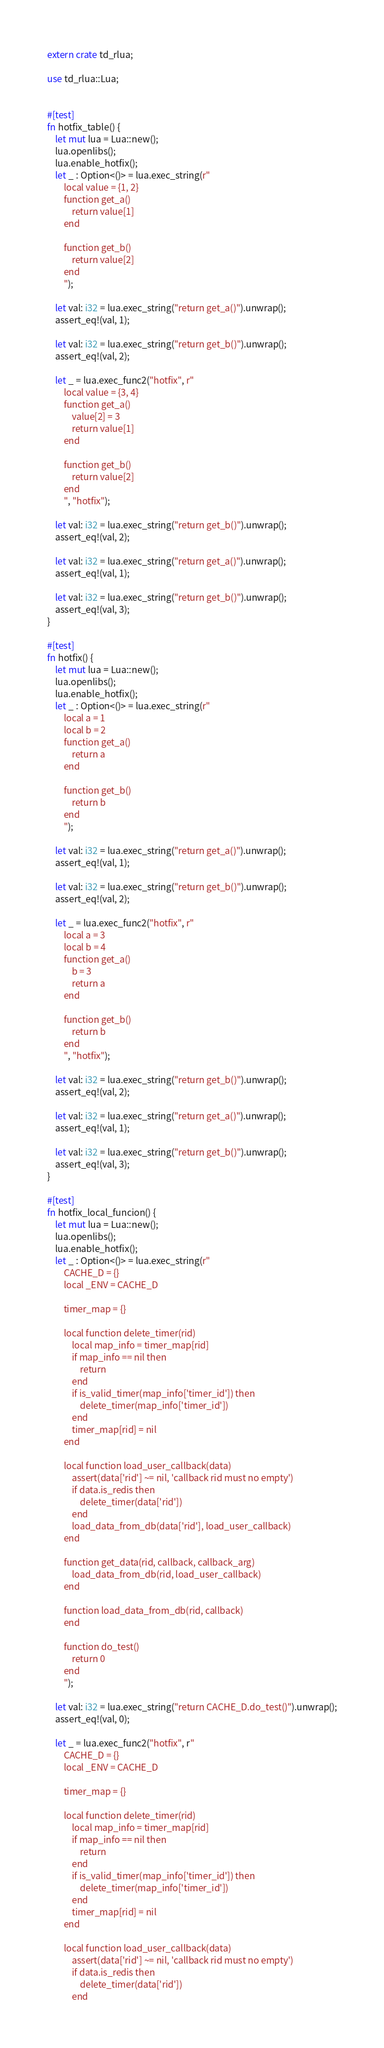<code> <loc_0><loc_0><loc_500><loc_500><_Rust_>extern crate td_rlua;

use td_rlua::Lua;


#[test]
fn hotfix_table() {
    let mut lua = Lua::new();
    lua.openlibs();
    lua.enable_hotfix();
    let _ : Option<()> = lua.exec_string(r"
        local value = {1, 2}
        function get_a()
            return value[1]
        end

        function get_b()
            return value[2]
        end
        ");

    let val: i32 = lua.exec_string("return get_a()").unwrap();
    assert_eq!(val, 1);

    let val: i32 = lua.exec_string("return get_b()").unwrap();
    assert_eq!(val, 2);

    let _ = lua.exec_func2("hotfix", r"
        local value = {3, 4}
        function get_a()
            value[2] = 3
            return value[1]
        end

        function get_b()
            return value[2]
        end
        ", "hotfix");

    let val: i32 = lua.exec_string("return get_b()").unwrap();
    assert_eq!(val, 2);

    let val: i32 = lua.exec_string("return get_a()").unwrap();
    assert_eq!(val, 1);

    let val: i32 = lua.exec_string("return get_b()").unwrap();
    assert_eq!(val, 3);
}

#[test]
fn hotfix() {
    let mut lua = Lua::new();
    lua.openlibs();
    lua.enable_hotfix();
    let _ : Option<()> = lua.exec_string(r"
        local a = 1
        local b = 2
        function get_a()
            return a
        end

        function get_b()
            return b
        end
        ");

    let val: i32 = lua.exec_string("return get_a()").unwrap();
    assert_eq!(val, 1);

    let val: i32 = lua.exec_string("return get_b()").unwrap();
    assert_eq!(val, 2);

    let _ = lua.exec_func2("hotfix", r"
        local a = 3
        local b = 4
        function get_a()
            b = 3
            return a
        end

        function get_b()
            return b
        end
        ", "hotfix");

    let val: i32 = lua.exec_string("return get_b()").unwrap();
    assert_eq!(val, 2);

    let val: i32 = lua.exec_string("return get_a()").unwrap();
    assert_eq!(val, 1);

    let val: i32 = lua.exec_string("return get_b()").unwrap();
    assert_eq!(val, 3);
}

#[test]
fn hotfix_local_funcion() {
    let mut lua = Lua::new();
    lua.openlibs();
    lua.enable_hotfix();
    let _ : Option<()> = lua.exec_string(r"
        CACHE_D = {}
        local _ENV = CACHE_D

        timer_map = {}

        local function delete_timer(rid)
            local map_info = timer_map[rid]
            if map_info == nil then
                return
            end
            if is_valid_timer(map_info['timer_id']) then
                delete_timer(map_info['timer_id'])
            end
            timer_map[rid] = nil
        end

        local function load_user_callback(data)
            assert(data['rid'] ~= nil, 'callback rid must no empty')
            if data.is_redis then
                delete_timer(data['rid'])
            end
            load_data_from_db(data['rid'], load_user_callback)
        end

        function get_data(rid, callback, callback_arg) 
            load_data_from_db(rid, load_user_callback)
        end

        function load_data_from_db(rid, callback)
        end

        function do_test()
            return 0
        end
        ");

    let val: i32 = lua.exec_string("return CACHE_D.do_test()").unwrap();
    assert_eq!(val, 0);

    let _ = lua.exec_func2("hotfix", r"
        CACHE_D = {}
        local _ENV = CACHE_D

        timer_map = {}

        local function delete_timer(rid)
            local map_info = timer_map[rid]
            if map_info == nil then
                return
            end
            if is_valid_timer(map_info['timer_id']) then
                delete_timer(map_info['timer_id'])
            end
            timer_map[rid] = nil
        end

        local function load_user_callback(data)
            assert(data['rid'] ~= nil, 'callback rid must no empty')
            if data.is_redis then
                delete_timer(data['rid'])
            end</code> 